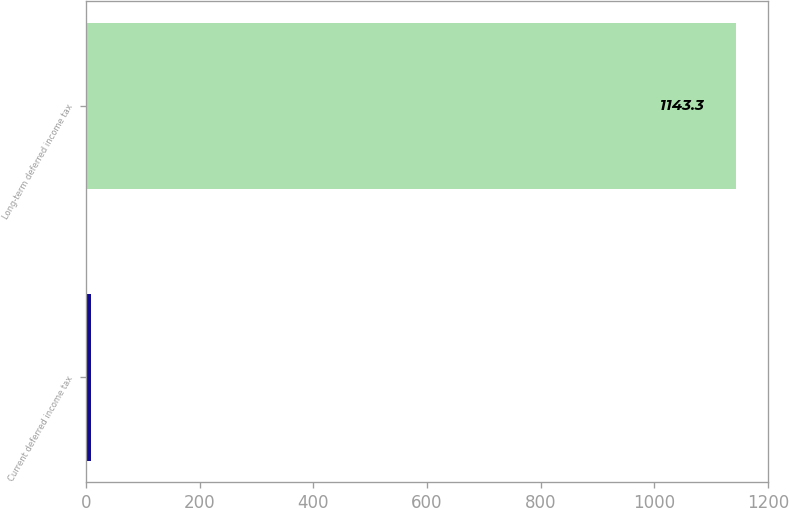<chart> <loc_0><loc_0><loc_500><loc_500><bar_chart><fcel>Current deferred income tax<fcel>Long-term deferred income tax<nl><fcel>8<fcel>1143.3<nl></chart> 